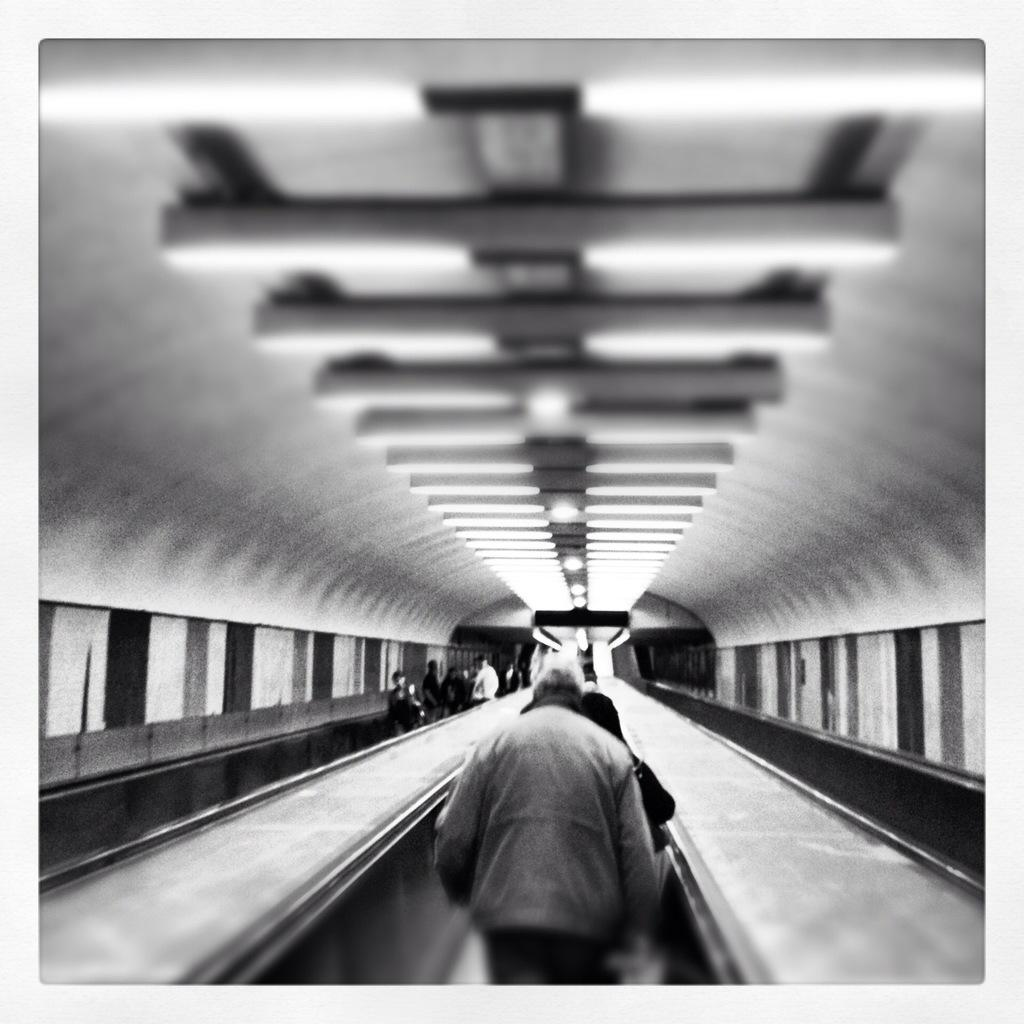Who or what is present in the image? There are people in the image. Can you describe any specific features or objects in the image? Yes, there is light on the roof in the image. What type of sign can be seen hanging from the roof in the image? There is no sign visible in the image; only light on the roof is mentioned. Are there any mittens or gloves present in the image? There is no mention of mittens or gloves in the image. 